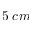Convert formula to latex. <formula><loc_0><loc_0><loc_500><loc_500>5 \, c m</formula> 